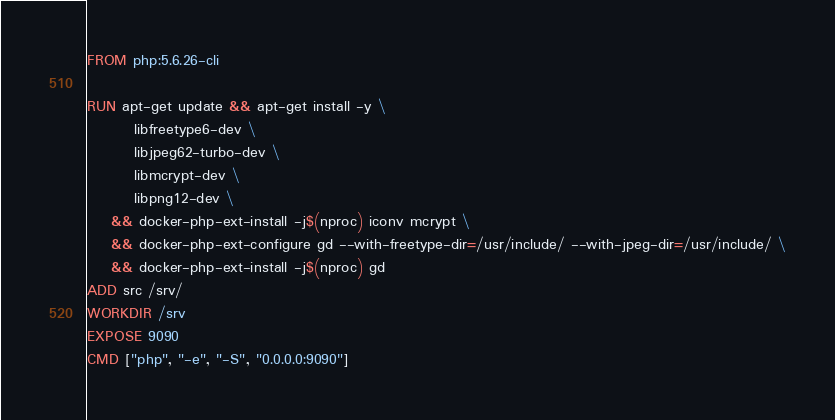<code> <loc_0><loc_0><loc_500><loc_500><_Dockerfile_>FROM php:5.6.26-cli

RUN apt-get update && apt-get install -y \
        libfreetype6-dev \
        libjpeg62-turbo-dev \
        libmcrypt-dev \
        libpng12-dev \
    && docker-php-ext-install -j$(nproc) iconv mcrypt \
    && docker-php-ext-configure gd --with-freetype-dir=/usr/include/ --with-jpeg-dir=/usr/include/ \
    && docker-php-ext-install -j$(nproc) gd
ADD src /srv/
WORKDIR /srv
EXPOSE 9090
CMD ["php", "-e", "-S", "0.0.0.0:9090"]</code> 